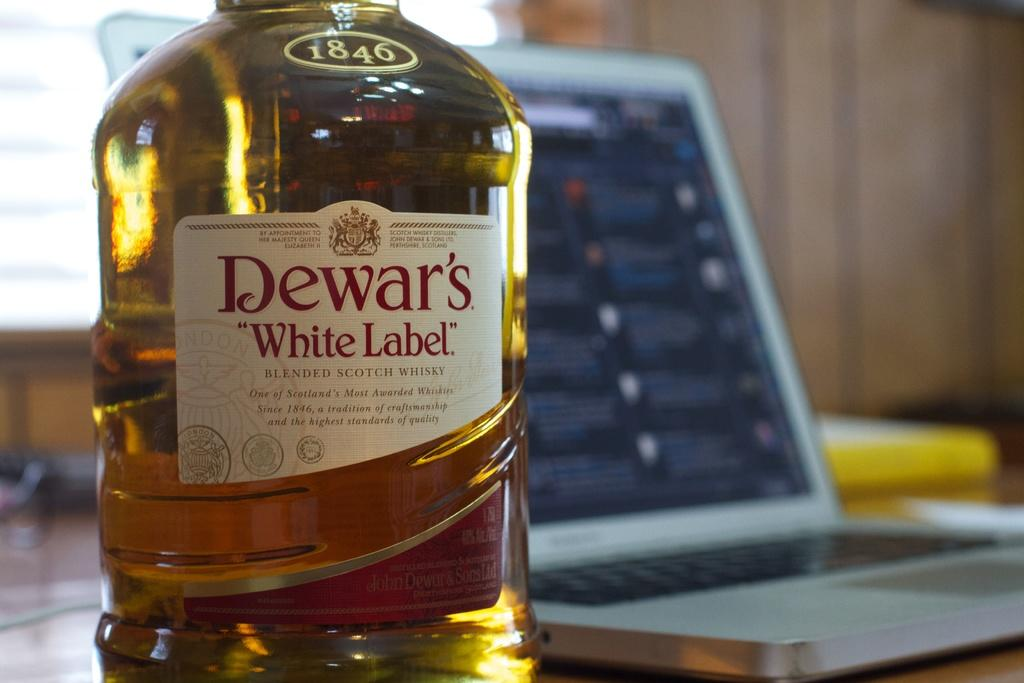<image>
Describe the image concisely. A bottle of Dewar's White Label sitting by a laptop. 